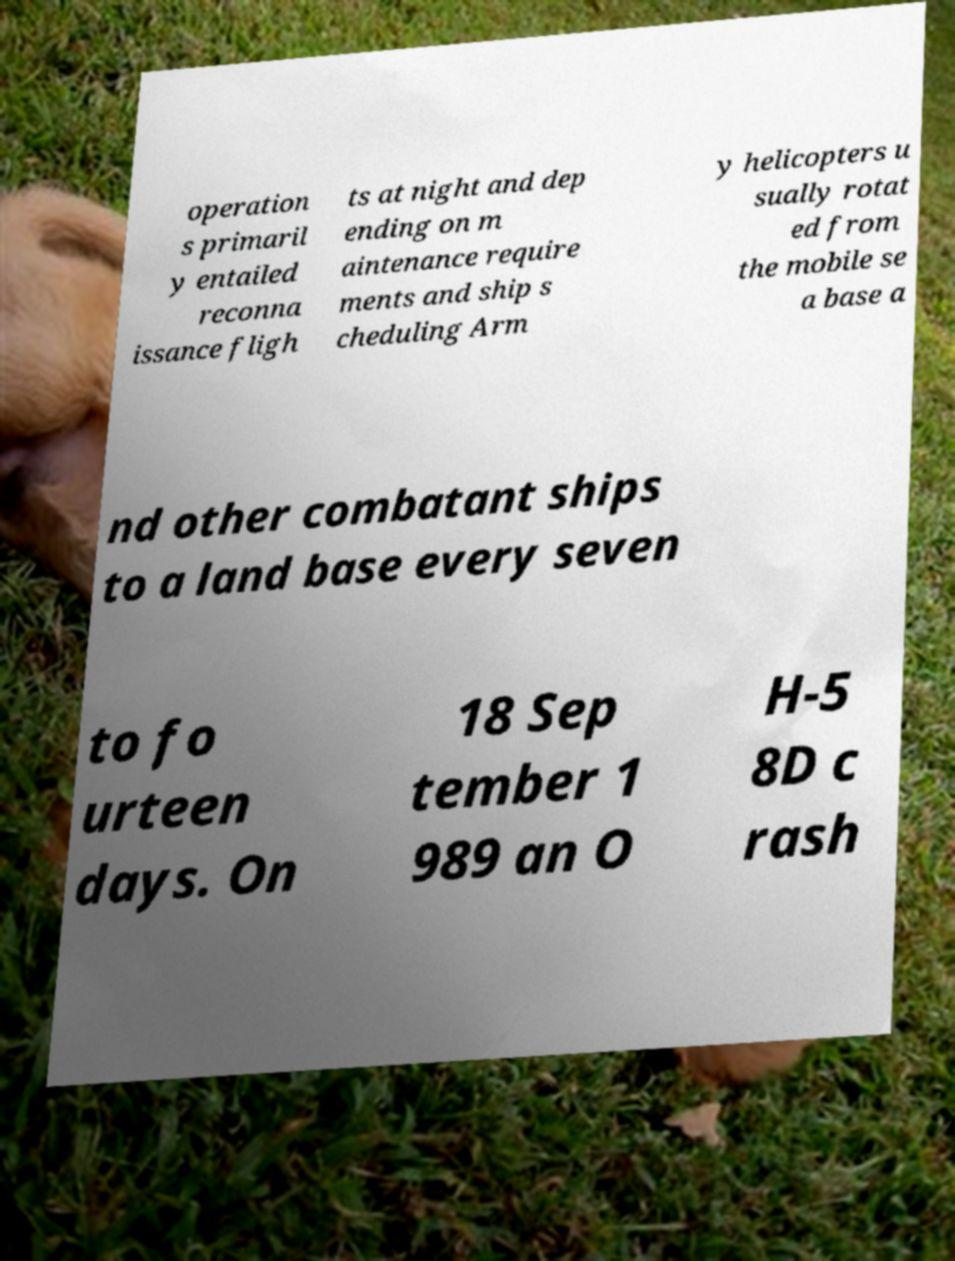For documentation purposes, I need the text within this image transcribed. Could you provide that? operation s primaril y entailed reconna issance fligh ts at night and dep ending on m aintenance require ments and ship s cheduling Arm y helicopters u sually rotat ed from the mobile se a base a nd other combatant ships to a land base every seven to fo urteen days. On 18 Sep tember 1 989 an O H-5 8D c rash 